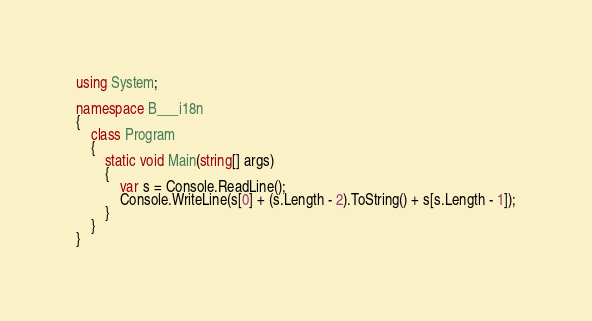<code> <loc_0><loc_0><loc_500><loc_500><_C#_>using System;

namespace B___i18n
{
    class Program
    {
        static void Main(string[] args)
        {
            var s = Console.ReadLine();
            Console.WriteLine(s[0] + (s.Length - 2).ToString() + s[s.Length - 1]);
        }
    }
}</code> 